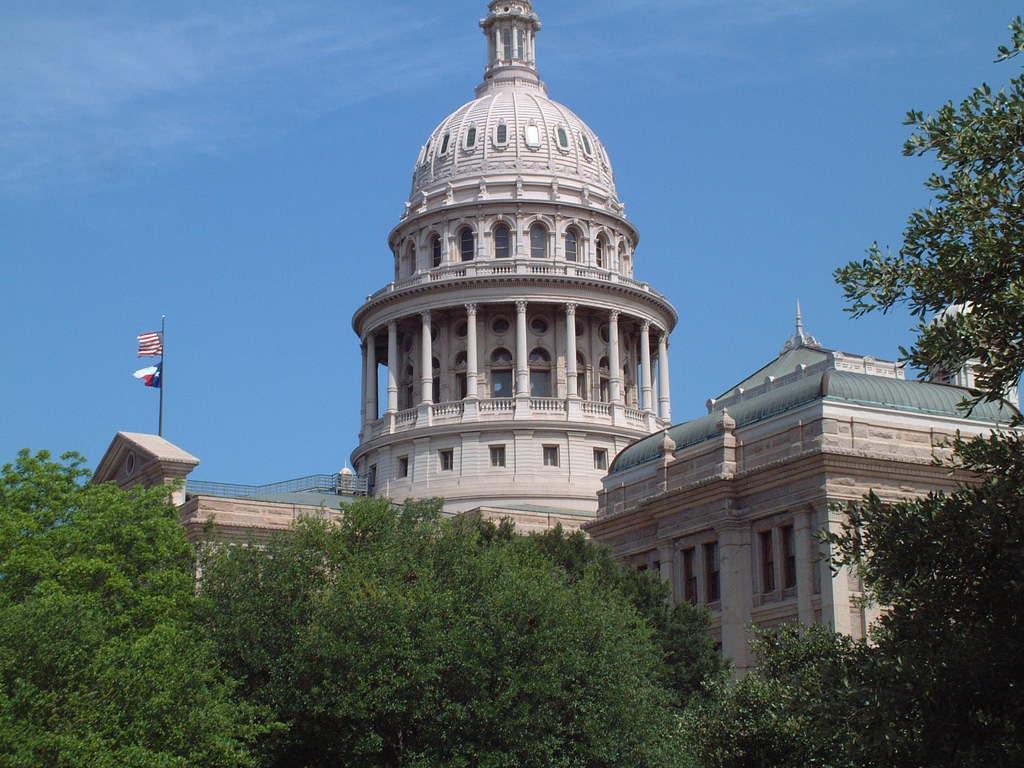How would you summarize this image in a sentence or two? In this image, I can see a building with windows and pillars. On the left side of the image, I can see two flags hanging to a pole, which is on top of a building. There are trees. In the background, I can see the sky. 